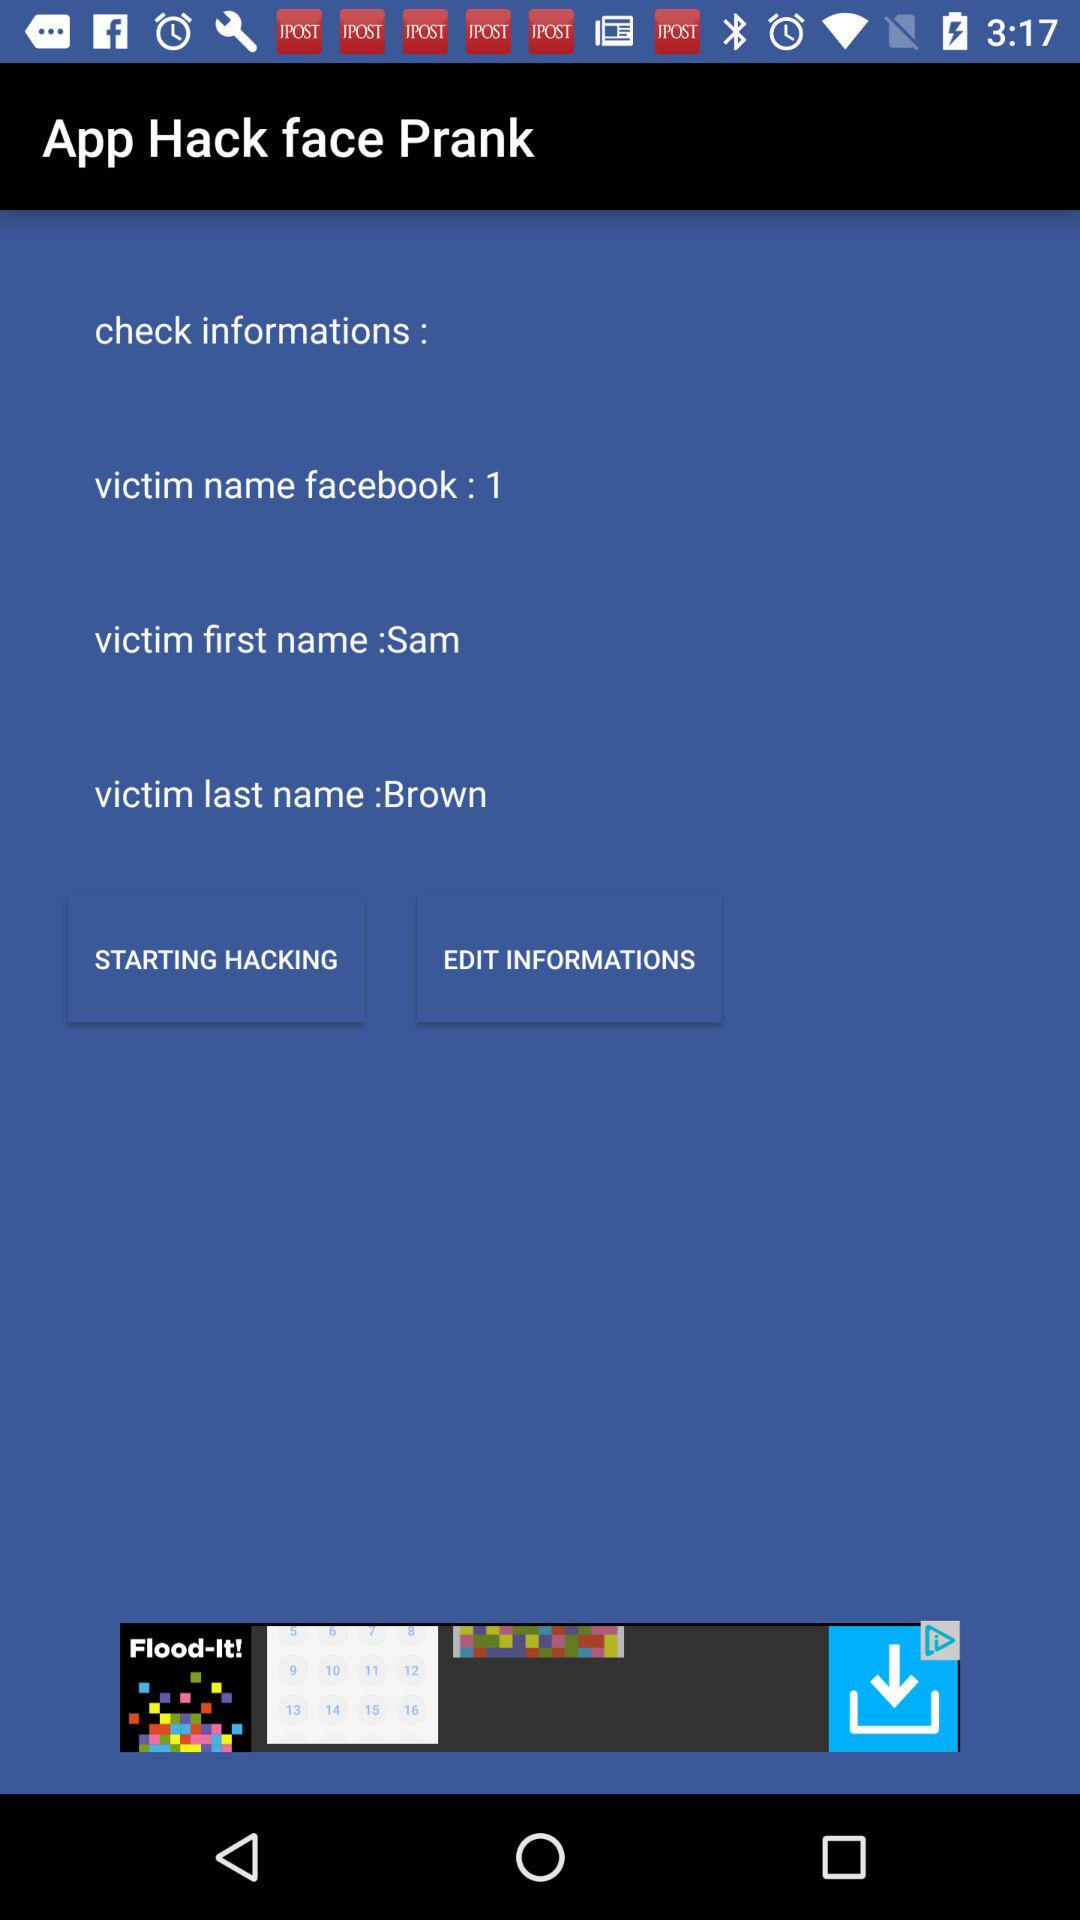What's the user "Facebook" account name? The user "Facebook" account name is Sam Brown. 